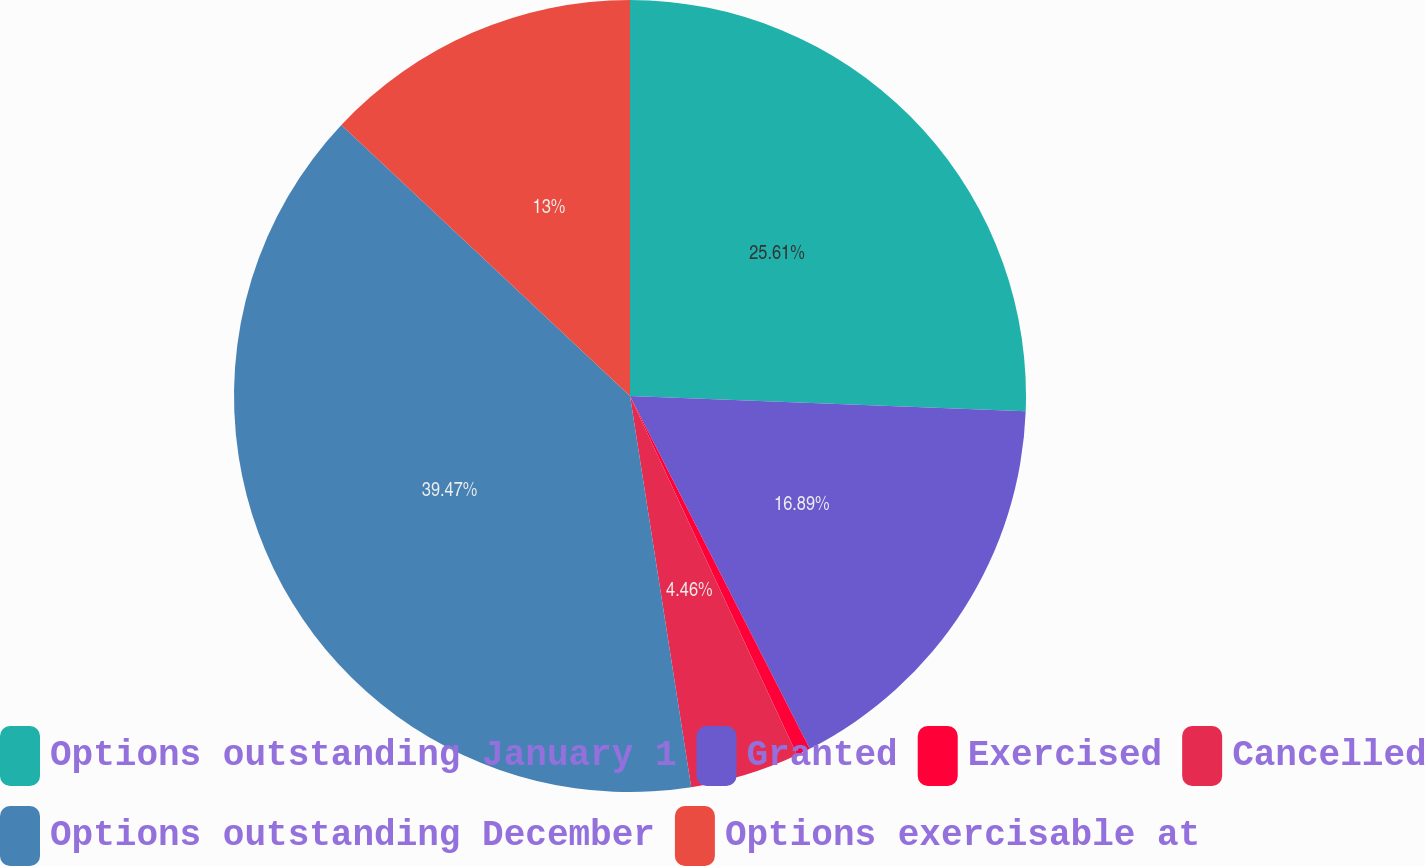<chart> <loc_0><loc_0><loc_500><loc_500><pie_chart><fcel>Options outstanding January 1<fcel>Granted<fcel>Exercised<fcel>Cancelled<fcel>Options outstanding December<fcel>Options exercisable at<nl><fcel>25.61%<fcel>16.89%<fcel>0.57%<fcel>4.46%<fcel>39.47%<fcel>13.0%<nl></chart> 